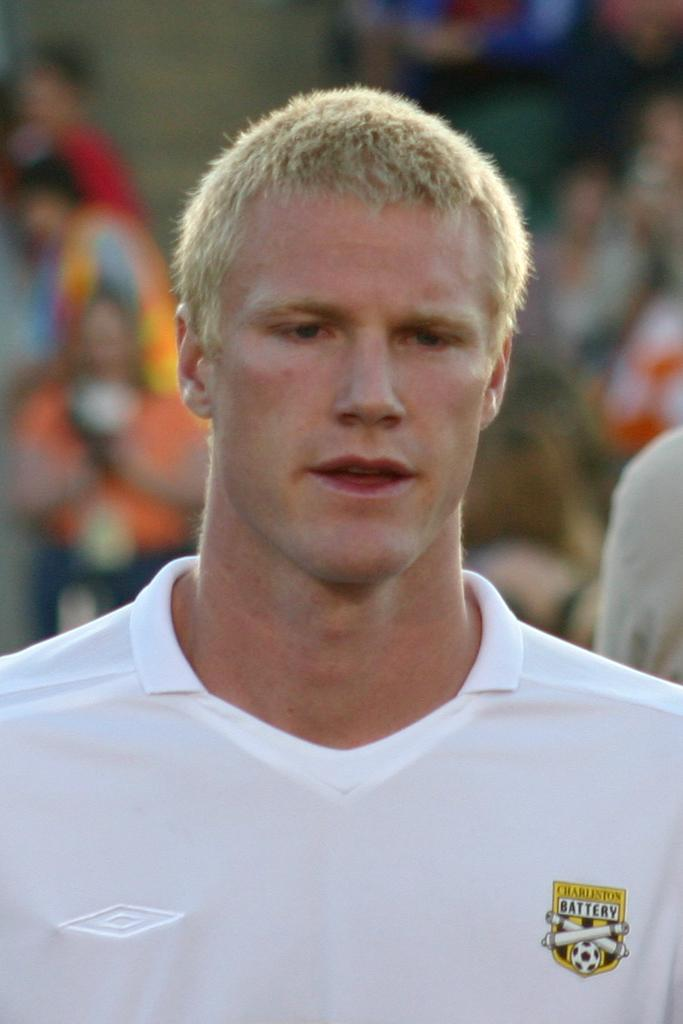<image>
Offer a succinct explanation of the picture presented. Man earing a white shirt that states Charleston Battery 